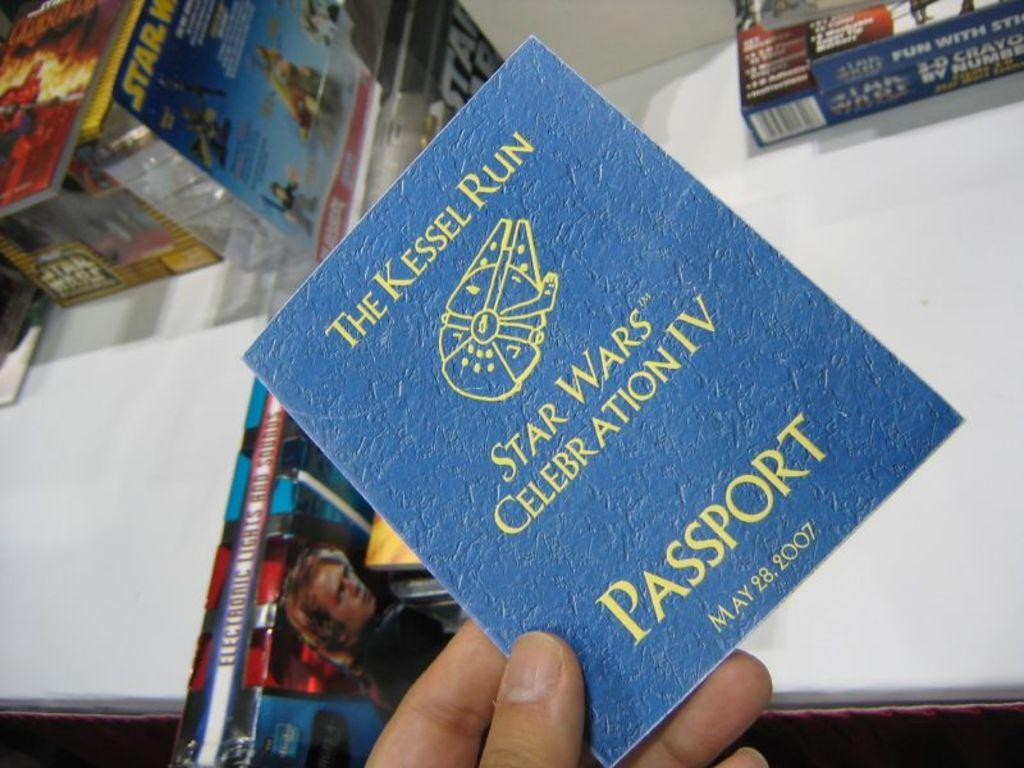<image>
Offer a succinct explanation of the picture presented. A blue Star Wars passport for Star Wars Celebration IV in 2007. 